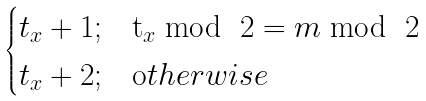<formula> <loc_0><loc_0><loc_500><loc_500>\begin{cases} t _ { x } + 1 ; & \text  t_{x} \bmod \ 2 = m \bmod \ 2 \\ t _ { x } + 2 ; & \text  otherwise  \end{cases}</formula> 